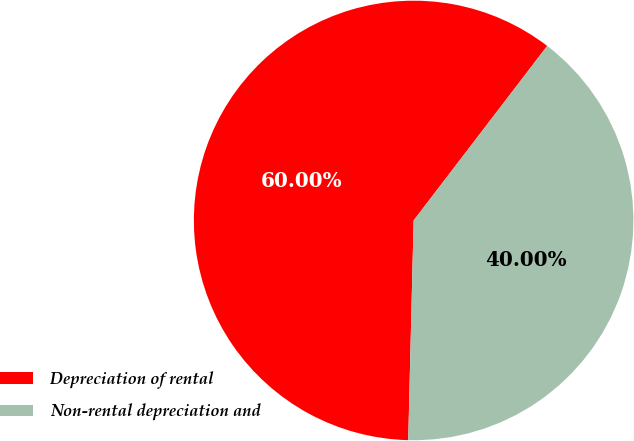Convert chart to OTSL. <chart><loc_0><loc_0><loc_500><loc_500><pie_chart><fcel>Depreciation of rental<fcel>Non-rental depreciation and<nl><fcel>60.0%<fcel>40.0%<nl></chart> 